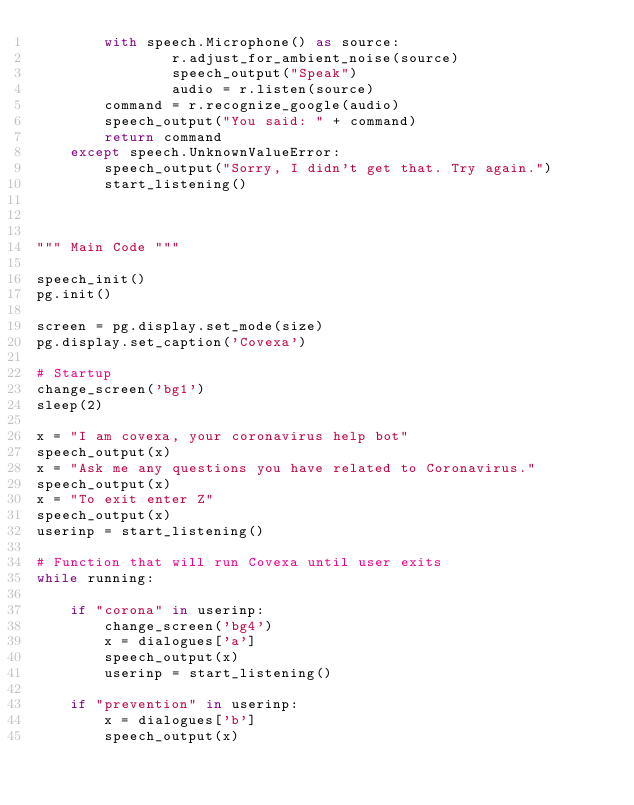Convert code to text. <code><loc_0><loc_0><loc_500><loc_500><_Python_>        with speech.Microphone() as source:
                r.adjust_for_ambient_noise(source) 
                speech_output("Speak")
                audio = r.listen(source)
        command = r.recognize_google(audio)
        speech_output("You said: " + command)
        return command 
    except speech.UnknownValueError:
        speech_output("Sorry, I didn't get that. Try again.")
        start_listening()
    
    

""" Main Code """
    
speech_init()
pg.init()

screen = pg.display.set_mode(size)
pg.display.set_caption('Covexa')

# Startup
change_screen('bg1')
sleep(2)

x = "I am covexa, your coronavirus help bot"
speech_output(x)
x = "Ask me any questions you have related to Coronavirus."
speech_output(x)
x = "To exit enter Z"
speech_output(x)
userinp = start_listening()

# Function that will run Covexa until user exits
while running:
    
    if "corona" in userinp:
        change_screen('bg4')
        x = dialogues['a']
        speech_output(x)
        userinp = start_listening()
        
    if "prevention" in userinp:
        x = dialogues['b']
        speech_output(x)</code> 